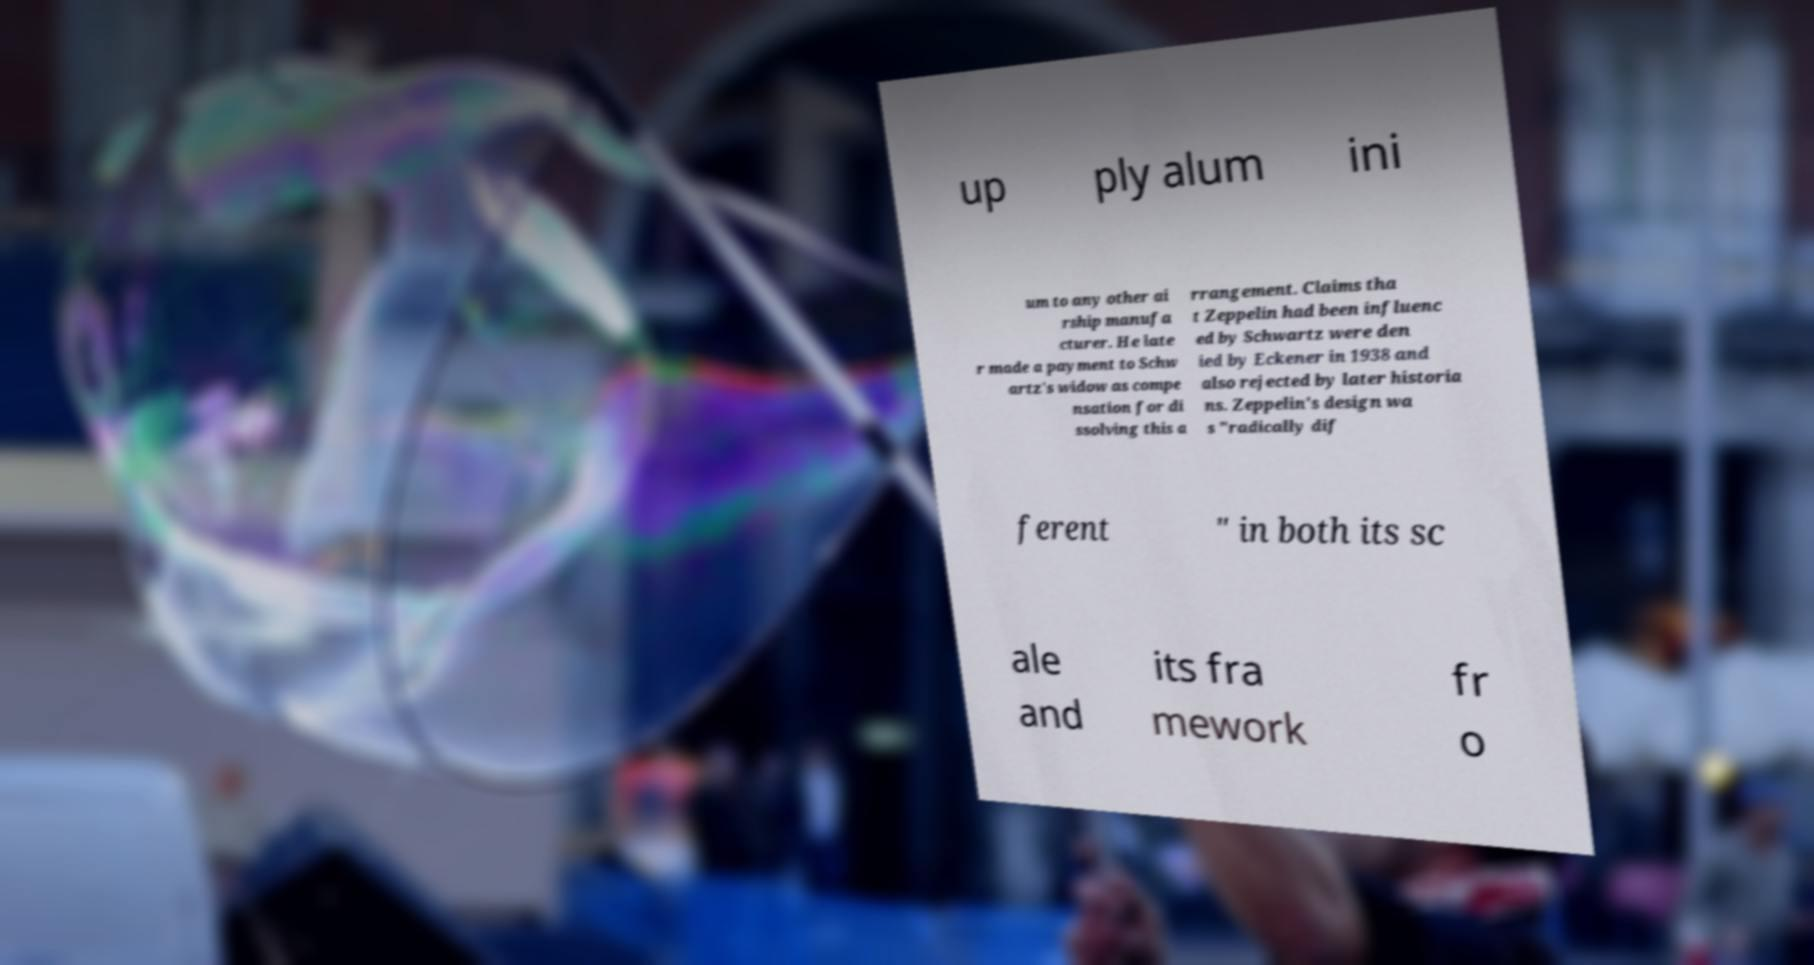What messages or text are displayed in this image? I need them in a readable, typed format. up ply alum ini um to any other ai rship manufa cturer. He late r made a payment to Schw artz's widow as compe nsation for di ssolving this a rrangement. Claims tha t Zeppelin had been influenc ed by Schwartz were den ied by Eckener in 1938 and also rejected by later historia ns. Zeppelin's design wa s "radically dif ferent " in both its sc ale and its fra mework fr o 